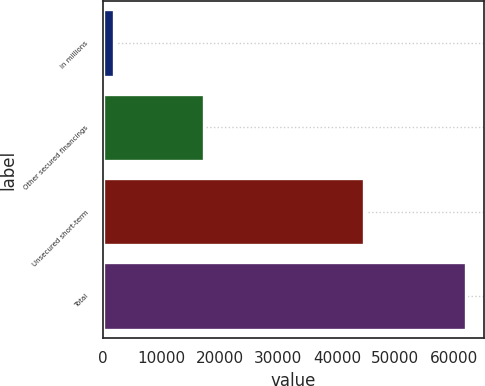Convert chart. <chart><loc_0><loc_0><loc_500><loc_500><bar_chart><fcel>in millions<fcel>Other secured financings<fcel>Unsecured short-term<fcel>Total<nl><fcel>2013<fcel>17290<fcel>44692<fcel>61982<nl></chart> 